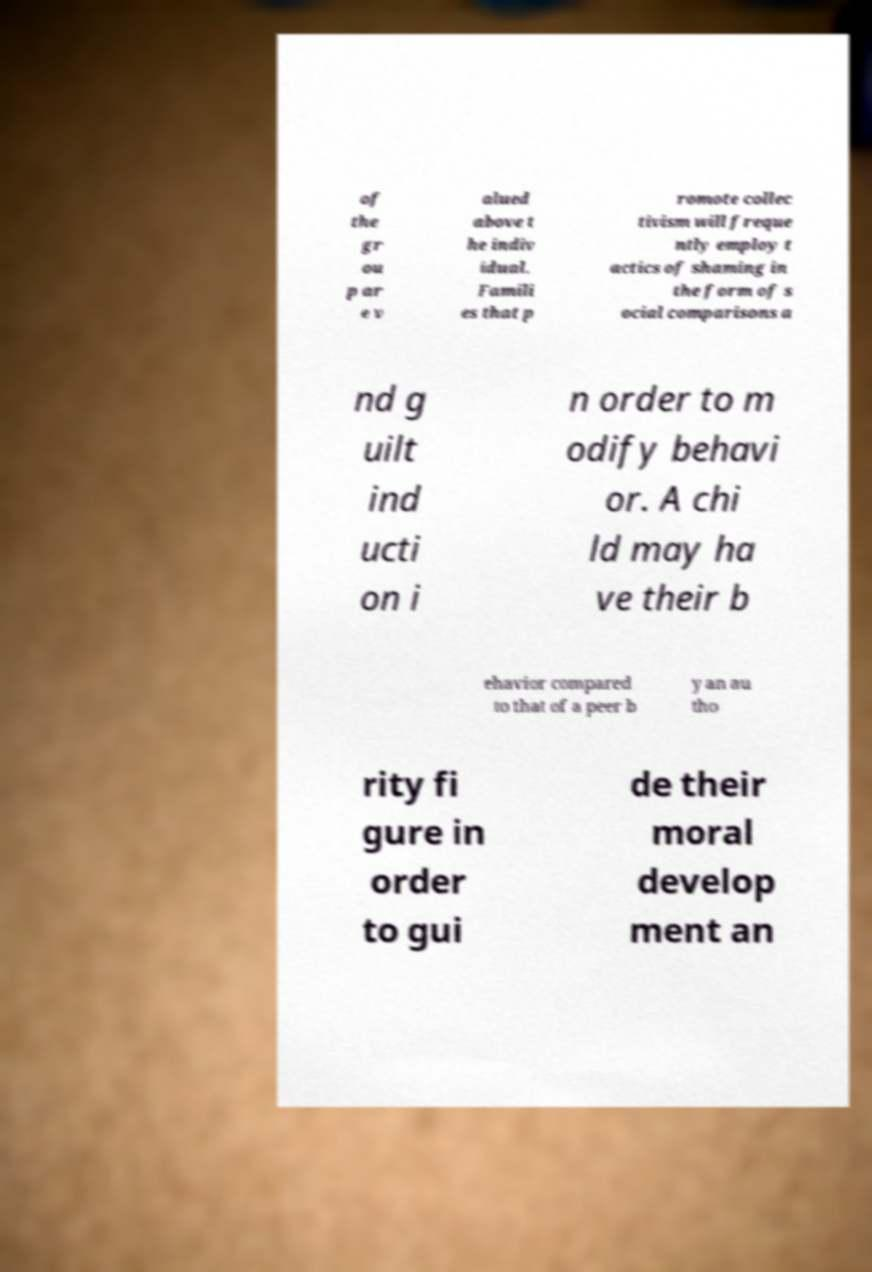Can you accurately transcribe the text from the provided image for me? of the gr ou p ar e v alued above t he indiv idual. Famili es that p romote collec tivism will freque ntly employ t actics of shaming in the form of s ocial comparisons a nd g uilt ind ucti on i n order to m odify behavi or. A chi ld may ha ve their b ehavior compared to that of a peer b y an au tho rity fi gure in order to gui de their moral develop ment an 